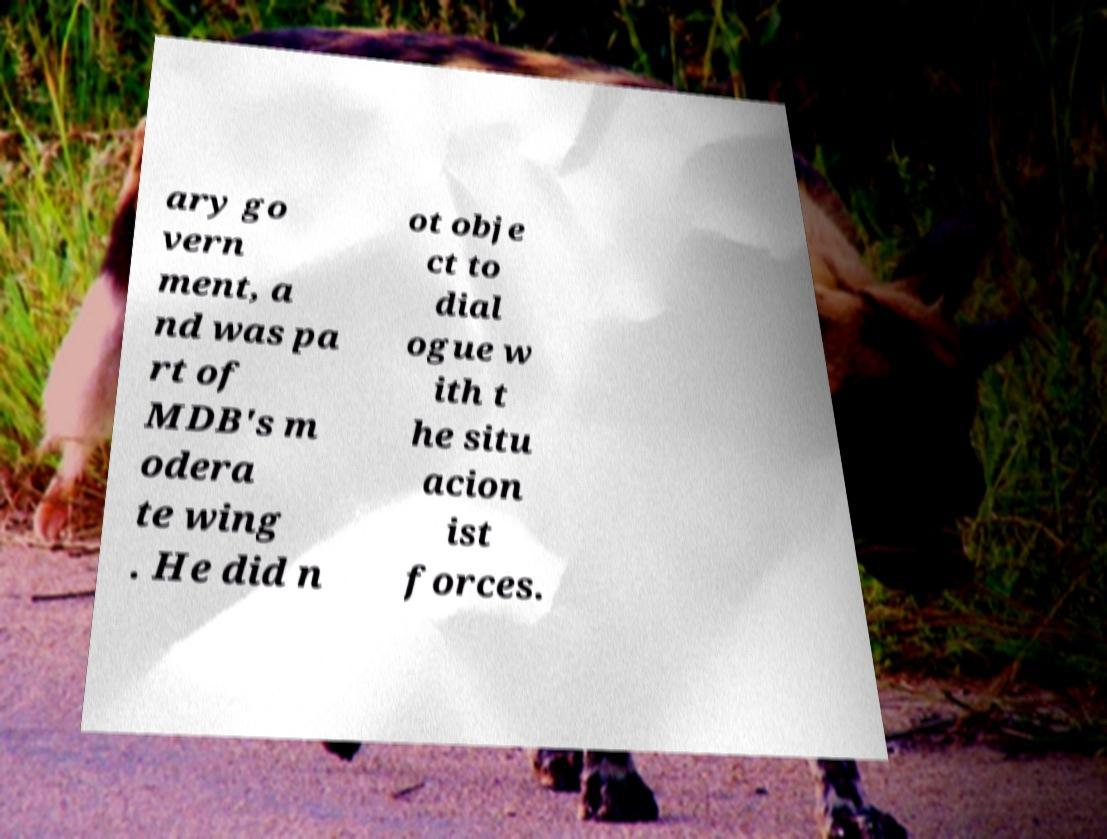What messages or text are displayed in this image? I need them in a readable, typed format. ary go vern ment, a nd was pa rt of MDB's m odera te wing . He did n ot obje ct to dial ogue w ith t he situ acion ist forces. 